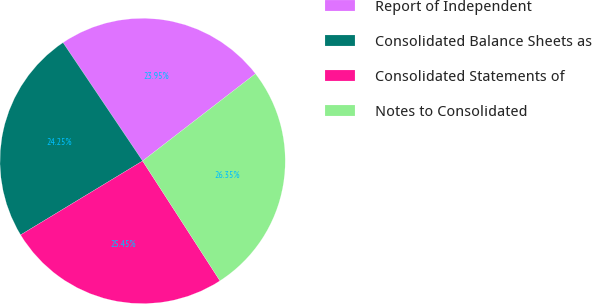Convert chart. <chart><loc_0><loc_0><loc_500><loc_500><pie_chart><fcel>Report of Independent<fcel>Consolidated Balance Sheets as<fcel>Consolidated Statements of<fcel>Notes to Consolidated<nl><fcel>23.95%<fcel>24.25%<fcel>25.45%<fcel>26.35%<nl></chart> 